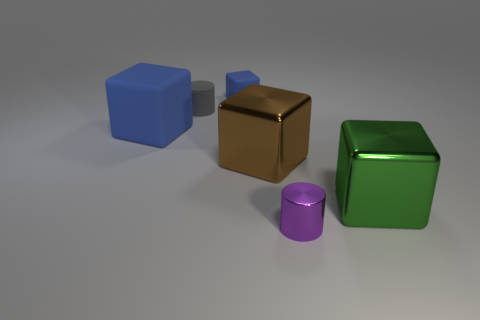Is there anything else that is the same color as the big rubber thing?
Provide a succinct answer. Yes. What is the size of the other block that is the same color as the big rubber block?
Keep it short and to the point. Small. How many big blocks are the same color as the small rubber cube?
Ensure brevity in your answer.  1. There is another object that is the same shape as the small gray rubber thing; what size is it?
Keep it short and to the point. Small. There is a large rubber cube; does it have the same color as the rubber thing that is right of the small gray cylinder?
Keep it short and to the point. Yes. Does the gray object have the same size as the cube that is on the left side of the gray rubber cylinder?
Your answer should be very brief. No. How many other objects are the same color as the small block?
Provide a succinct answer. 1. Are there more blue objects that are in front of the gray cylinder than large gray matte things?
Provide a short and direct response. Yes. There is a object to the right of the purple metallic object that is on the right side of the big shiny block to the left of the metal cylinder; what is its color?
Provide a succinct answer. Green. Do the tiny blue cube and the big blue object have the same material?
Provide a short and direct response. Yes. 